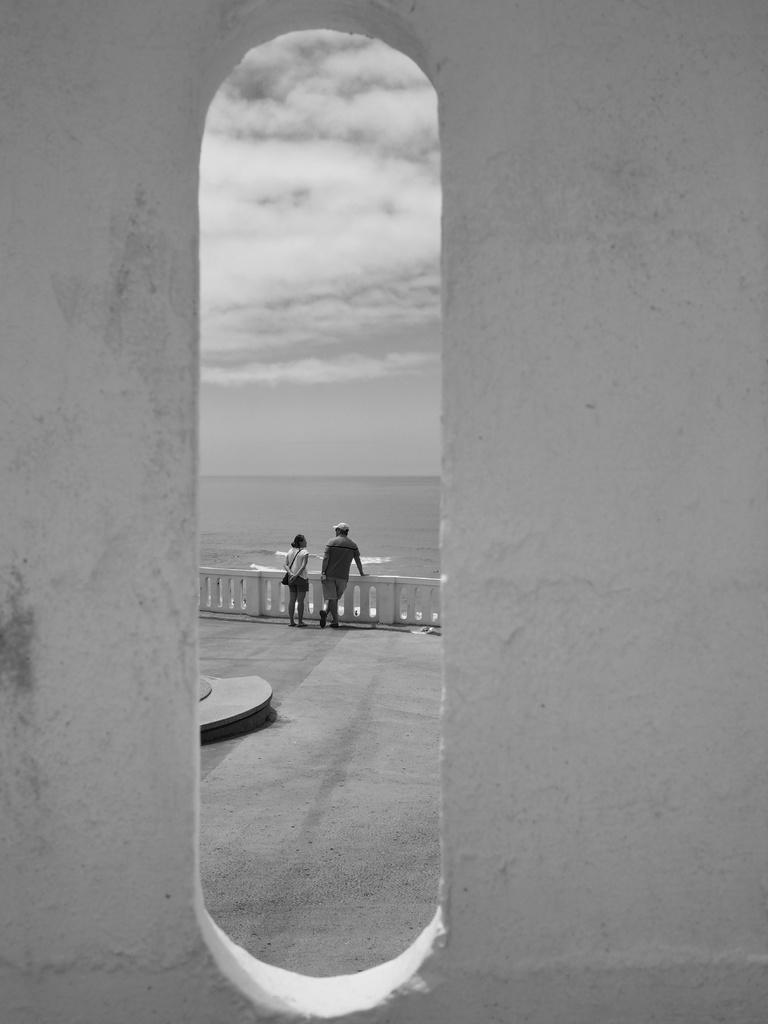What is located in the center of the image? There is a wall in the center of the image. What can be seen in the background of the image? The sky, clouds, water, two persons, and a fence are visible in the background. How many people are present in the image? Two persons are standing in the background. How many hydrants can be seen in the image? There are no hydrants present in the image. What type of guide is assisting the two persons in the image? There is no guide present in the image; only two persons are visible. 